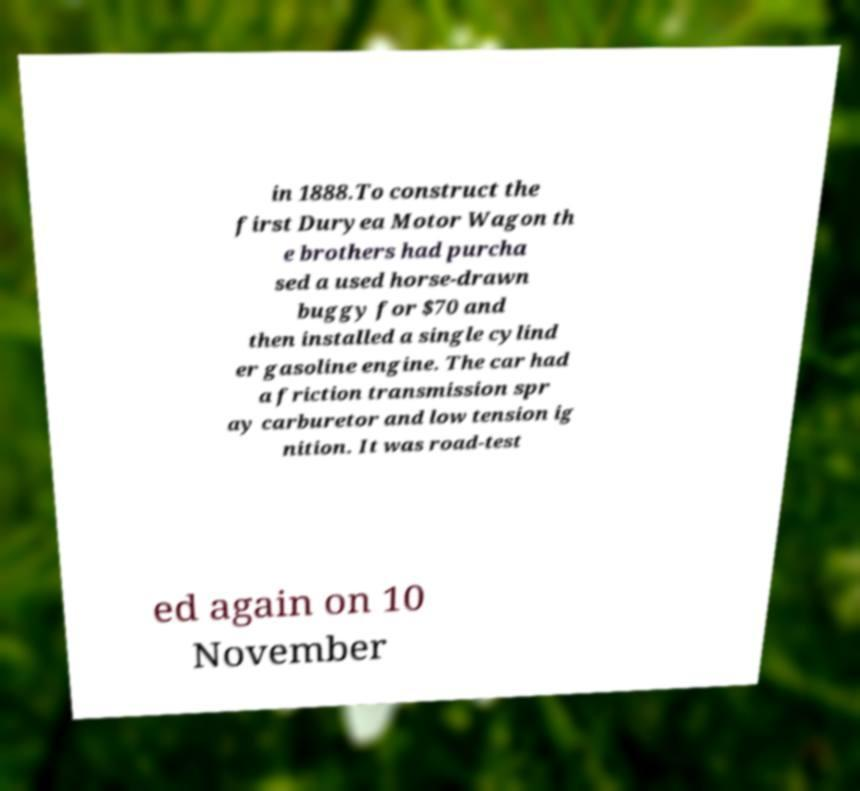What messages or text are displayed in this image? I need them in a readable, typed format. in 1888.To construct the first Duryea Motor Wagon th e brothers had purcha sed a used horse-drawn buggy for $70 and then installed a single cylind er gasoline engine. The car had a friction transmission spr ay carburetor and low tension ig nition. It was road-test ed again on 10 November 